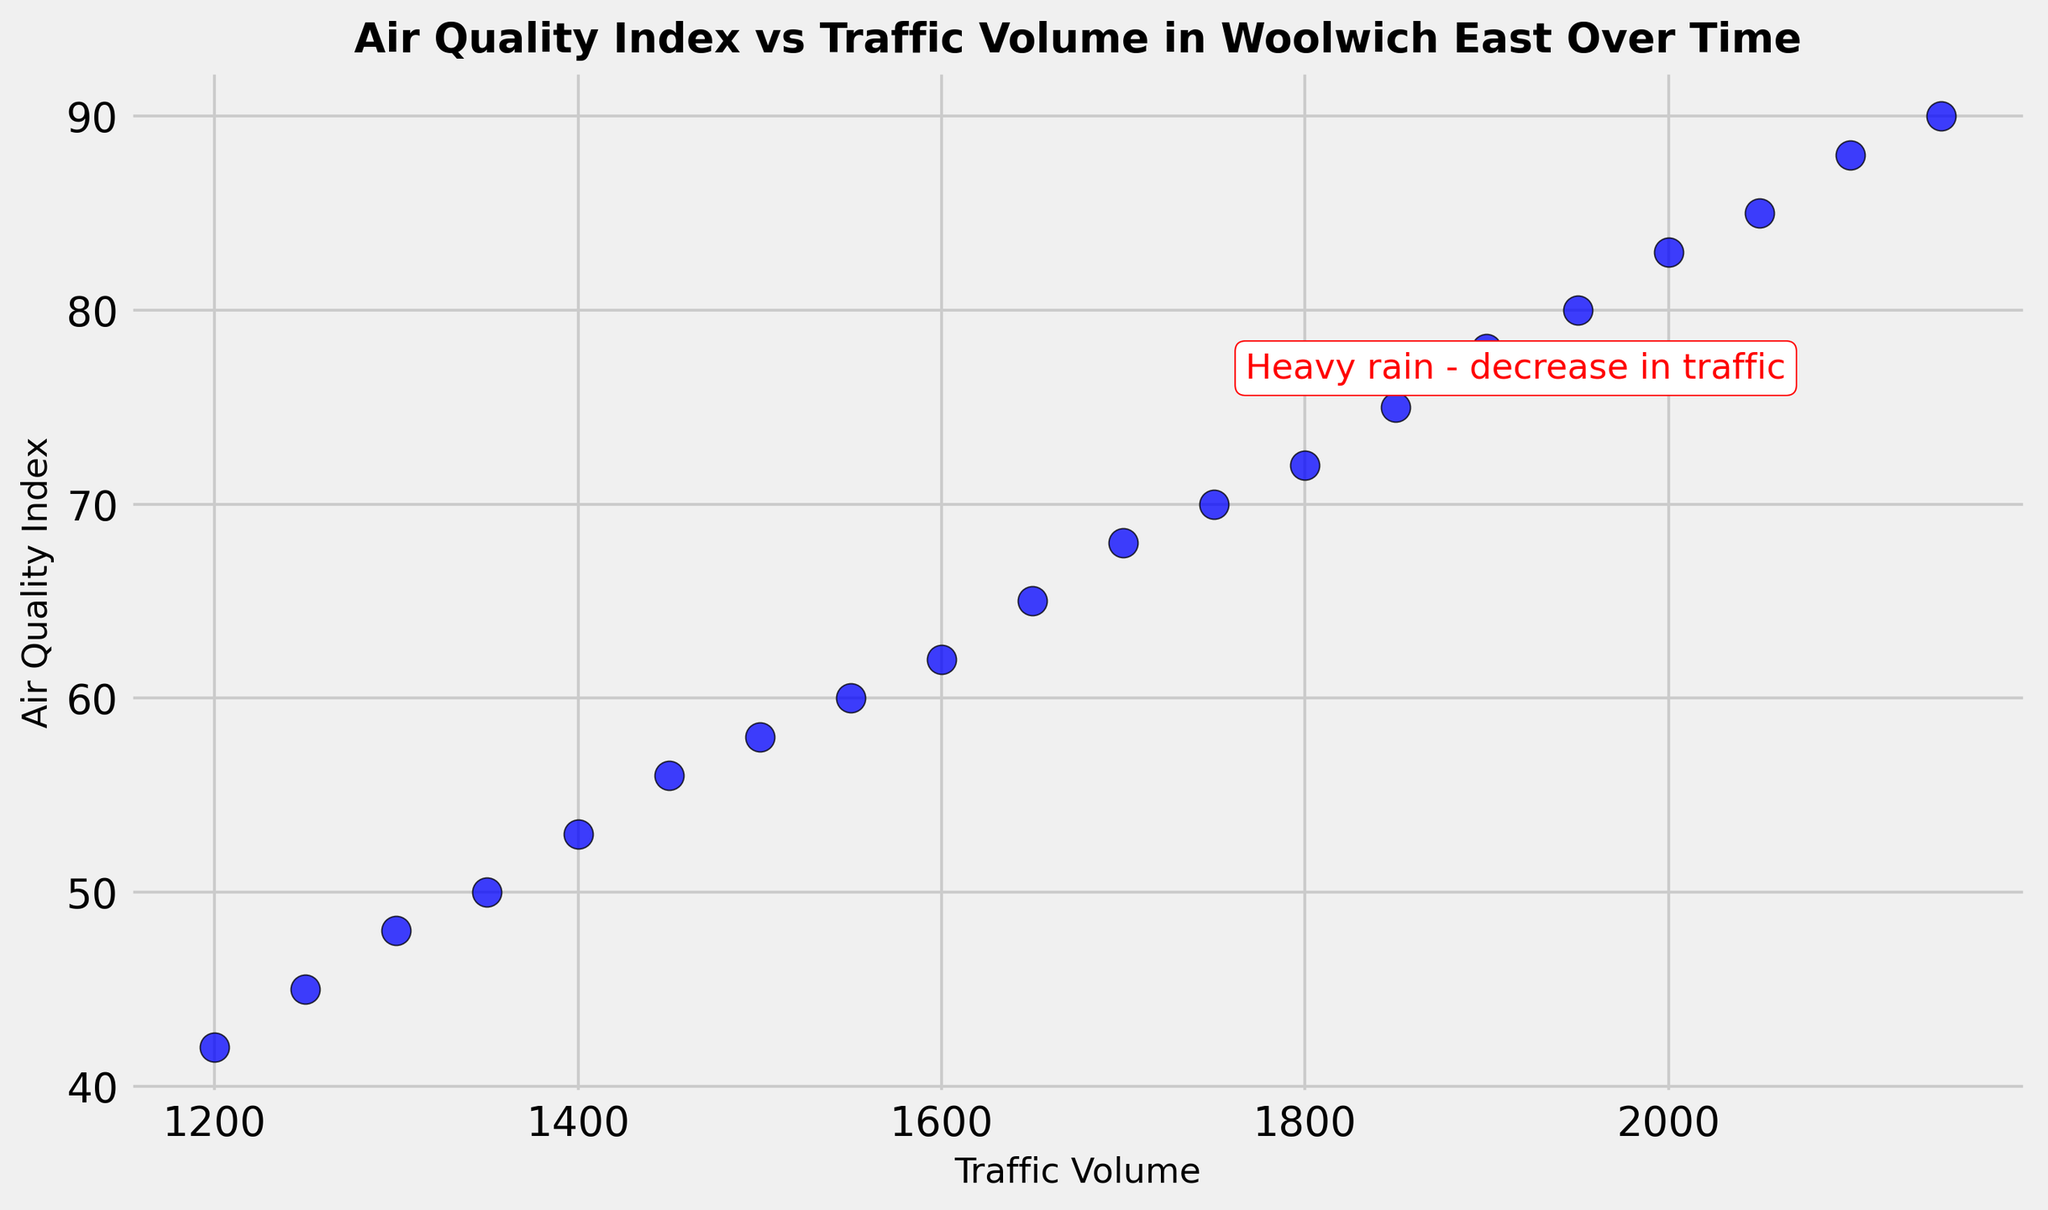Is there a relationship between traffic volume and air quality index? By observing the scatter plot, we can visually assess whether the points form a pattern. Specifically, we see that as the traffic volume increases, the Air Quality Index (AQI) also increases, indicating a positive correlation.
Answer: Yes, there is a positive correlation What is the AQI value annotated by the red text in the plot? The annotation "Heavy rain - decrease in traffic" is associated with the data point where the AQI is 78.
Answer: 78 Which day had the highest AQI, based on the traffic volume shown? The scatter plot shows that the highest AQI value (90) corresponds to the highest traffic volume (2150). Therefore, the day this occurred was 2023-01-20.
Answer: 2023-01-20 What is the general trend in AQI as traffic volume increases? By examining the plot, it’s clear that the AQI values rise as the traffic volume increases, suggesting a general upward trend.
Answer: Upward trend On which day did heavy rain cause a decrease in traffic, as noted in the annotation? The annotation "Heavy rain - decrease in traffic" is visible near the data point with an AQI of 78 and traffic volume of 1900. The corresponding date is 2023-01-15.
Answer: 2023-01-15 Compare the AQI on the first and last day presented in the data. Is it higher or lower on the last day? The AQI on 2023-01-01 is 42, and on 2023-01-20, it is 90. Thus, the AQI is higher on the last day.
Answer: Higher What was the traffic volume on the day with an AQI of 60? Locate the point on the scatter plot where the AQI is 60; the corresponding traffic volume for that day is 1550.
Answer: 1550 Is there a significant change in traffic volume or AQI after the annotated "heavy rain" day? Compare the points immediately before and after the annotated day (2023-01-15). The traffic volume and AQI continue to rise steadily after 2023-01-15, so no drastic change is observed.
Answer: No significant change What is the average AQI for the first week (2023-01-01 to 2023-01-07)? AQI values for the first week are 42, 45, 48, 50, 53, 56, and 58. Sum these values: 42 + 45 + 48 + 50 + 53 + 56 + 58 = 352. Divide by 7 (the number of days): 352 / 7 = 50.28.
Answer: 50.28 Determine the highest and lowest AQI values from the scatter plot. The highest AQI value on the plot is 90, while the lowest is 42. By visually verifying the extremes of the data points, these values are confirmed.
Answer: Highest: 90, Lowest: 42 How many days show an AQI higher than 75? By counting the points on the scatter plot with AQI values greater than 75, we find the values to be on 2023-01-15, 2023-01-16, 2023-01-17, 2023-01-18, 2023-01-19, and 2023-01-20.
Answer: 6 days 